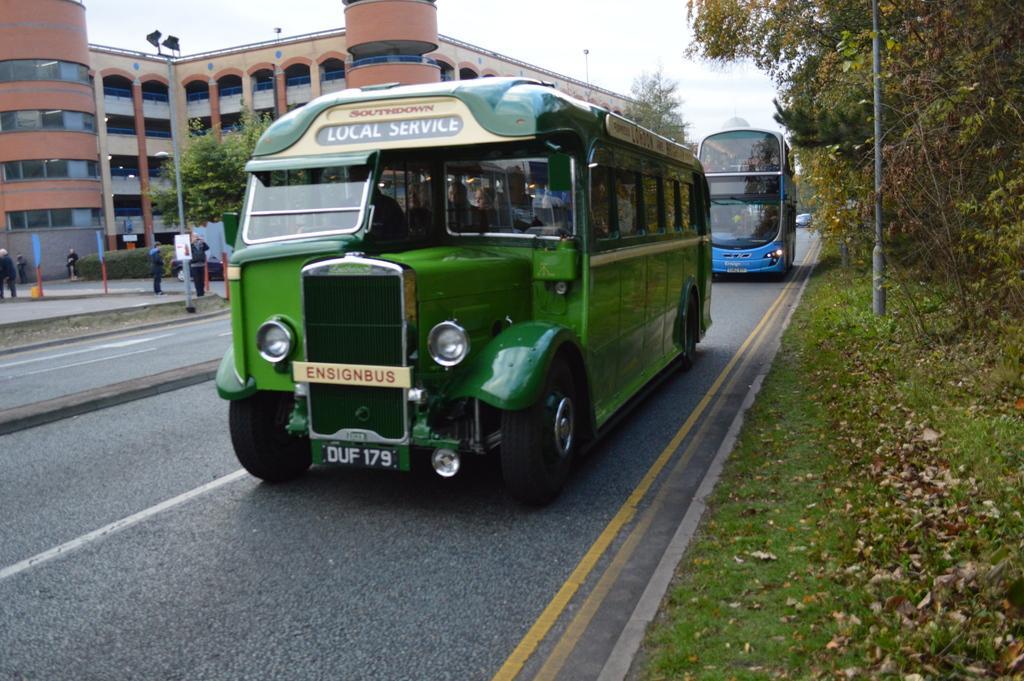Describe this image in one or two sentences. In this picture I can see couple of buses on the road and few people are standing. I can see pole lights and buildings in the back and I can see trees, plants and a cloudy sky. 